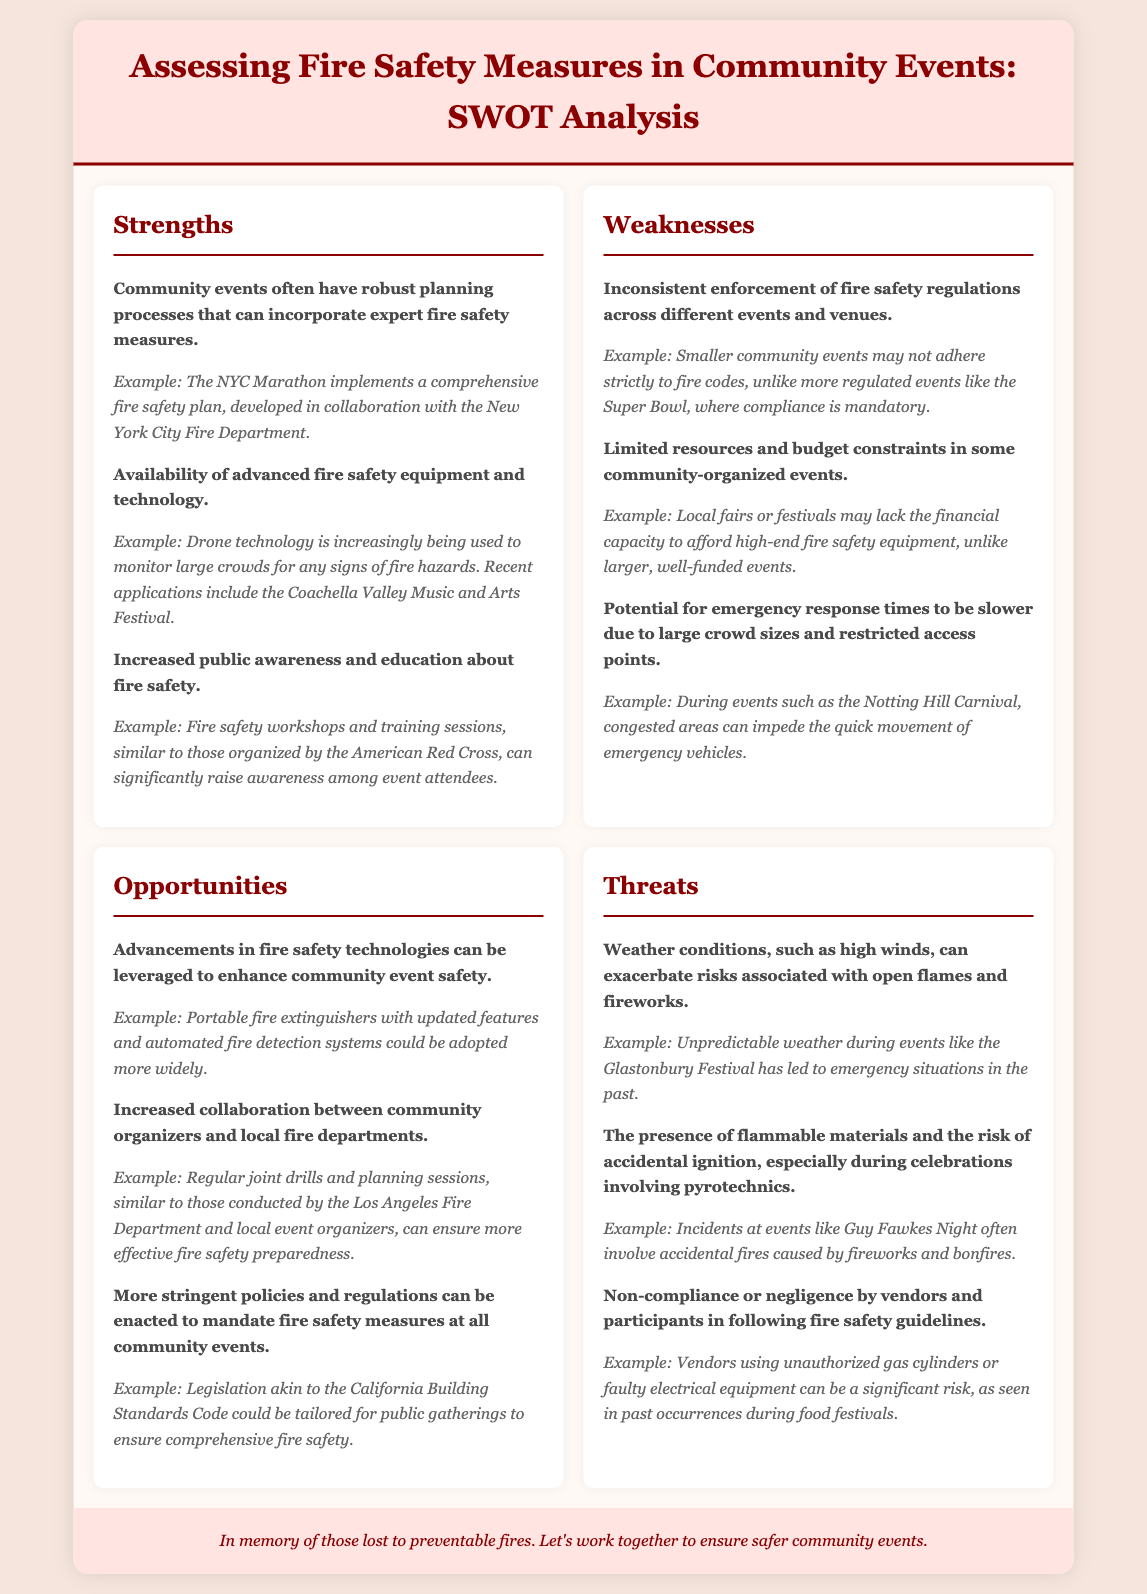what is one strength of community events related to fire safety? The document states that community events often have robust planning processes that can incorporate expert fire safety measures, which is a specific strength highlighted in the strengths section.
Answer: robust planning processes what is one example of a weakness noted in event fire safety? The document mentions that inconsistent enforcement of fire safety regulations across different events and venues is a noted weakness, with specific examples provided in that section.
Answer: inconsistent enforcement which technology is mentioned as being increasingly used in fire safety during events? The document highlights drone technology as being used to monitor large crowds for signs of fire hazards, which aligns with the strengths provided.
Answer: drone technology what opportunity is suggested for enhancing community event safety? Advancements in fire safety technologies are cited as an opportunity for enhancing community event safety, as stated in the opportunities section.
Answer: advancements in fire safety technologies what is a significant threat mentioned in relation to fireworks at events? The document states that the presence of flammable materials and the risk of accidental ignition during celebrations involving pyrotechnics is a significant threat noted under threats.
Answer: accidental ignition how does community awareness of fire safety improve? Increased public awareness and education about fire safety is mentioned in the strengths section, indicating how community knowledge can improve safety.
Answer: education about fire safety what initiative can improve fire safety measures in community events? The increased collaboration between community organizers and local fire departments is suggested as an initiative to improve fire safety in the opportunities section.
Answer: collaboration how does bad weather influence fire incidents at events? The document states that weather conditions, such as high winds, can exacerbate risks associated with open flames and fireworks, emphasizing the impact of weather.
Answer: exacerbate risks which organization is mentioned as an example for raising awareness in fire safety workshops? The American Red Cross is cited as an example of an organization organizing fire safety workshops in the strengths section.
Answer: American Red Cross 